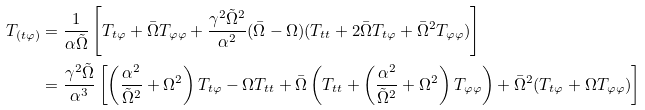Convert formula to latex. <formula><loc_0><loc_0><loc_500><loc_500>T _ { ( t \varphi ) } & = \frac { 1 } { \alpha \tilde { \Omega } } \left [ T _ { t \varphi } + \bar { \Omega } T _ { \varphi \varphi } + \frac { \gamma ^ { 2 } \tilde { \Omega } ^ { 2 } } { \alpha ^ { 2 } } ( \bar { \Omega } - \Omega ) ( T _ { t t } + 2 \bar { \Omega } T _ { t \varphi } + \bar { \Omega } ^ { 2 } T _ { \varphi \varphi } ) \right ] \\ & = \frac { \gamma ^ { 2 } \tilde { \Omega } } { \alpha ^ { 3 } } \left [ \left ( \frac { \alpha ^ { 2 } } { \tilde { \Omega } ^ { 2 } } + \Omega ^ { 2 } \right ) T _ { t \varphi } - \Omega T _ { t t } + \bar { \Omega } \left ( T _ { t t } + \left ( \frac { \alpha ^ { 2 } } { \tilde { \Omega } ^ { 2 } } + \Omega ^ { 2 } \right ) T _ { \varphi \varphi } \right ) + \bar { \Omega } ^ { 2 } ( T _ { t \varphi } + \Omega T _ { \varphi \varphi } ) \right ]</formula> 